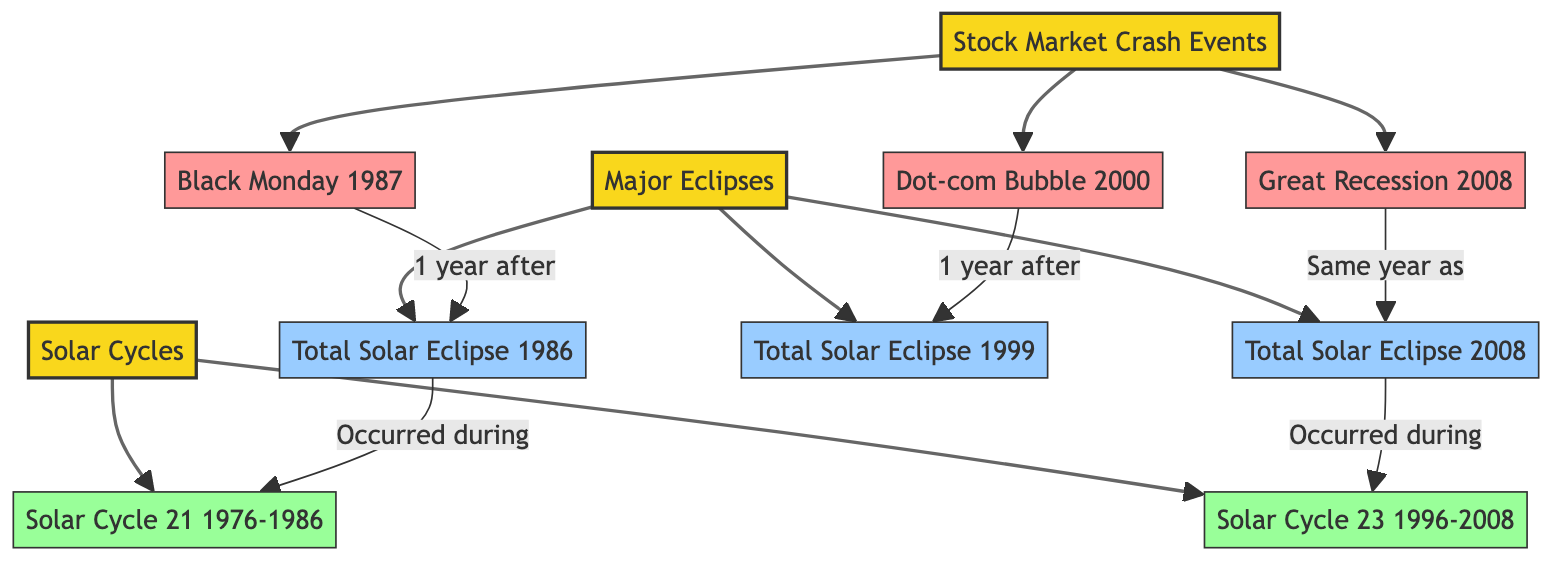What are the three stock market crash events listed? The diagram identifies three stock market crash events: Black Monday 1987, Dot-com Bubble 2000, and Great Recession 2008, which are connected to the Stock Market Crash Events node.
Answer: Black Monday 1987, Dot-com Bubble 2000, Great Recession 2008 Which total solar eclipse occurred in 1999? The diagram explicitly labels the total solar eclipse that took place in 1999 as the Total Solar Eclipse 1999, linked to the Major Eclipses node.
Answer: Total Solar Eclipse 1999 How many solar cycles are represented in the diagram? The diagram shows two solar cycles: Solar Cycle 21 and Solar Cycle 23, leading to a total count of nodes associated with solar cycles.
Answer: 2 What event occurred the same year as the Total Solar Eclipse in 2008? The diagram connects the Great Recession 2008 with the Total Solar Eclipse 2008 by stating they occurred in the same year, providing a direct answer drawn from the links and relationships.
Answer: Great Recession 2008 Which solar cycle occurred during the Total Solar Eclipse in 1986? The diagram denotes that the Total Solar Eclipse 1986 is associated with Solar Cycle 21 by indicating a direct relationship with that cycle, allowing us to trace the correlation.
Answer: Solar Cycle 21 What is the relationship between Black Monday and the Total Solar Eclipse in 1986? The diagram indicates that Black Monday occurred one year after the Total Solar Eclipse 1986, connecting these two events in a sequential manner.
Answer: 1 year after Which stock market event is linked to Solar Cycle 23? The diagram connects the Great Recession 2008 and the Total Solar Eclipse 2008 to Solar Cycle 23, establishing that both events are associated with this solar cycle.
Answer: Great Recession 2008 What color represents the stock market crash events in the diagram? In the diagram, the stock market crash events are represented with a color filled in pink, designated for event nodes, thereby clearly indicating their category.
Answer: Pink How many major eclipses are illustrated in the diagram? The diagram lists three total solar eclipses (Total Solar Eclipse 1986, Total Solar Eclipse 1999, and Total Solar Eclipse 2008), which can be counted from the node connections under Major Eclipses.
Answer: 3 